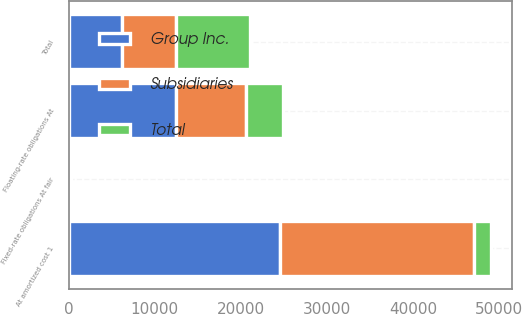<chart> <loc_0><loc_0><loc_500><loc_500><stacked_bar_chart><ecel><fcel>Fixed-rate obligations At fair<fcel>At amortized cost 1<fcel>Floating-rate obligations At<fcel>Total<nl><fcel>Subsidiaries<fcel>28<fcel>22500<fcel>8166<fcel>6235.5<nl><fcel>Total<fcel>94<fcel>2047<fcel>4305<fcel>8626<nl><fcel>Group Inc.<fcel>122<fcel>24547<fcel>12471<fcel>6235.5<nl></chart> 